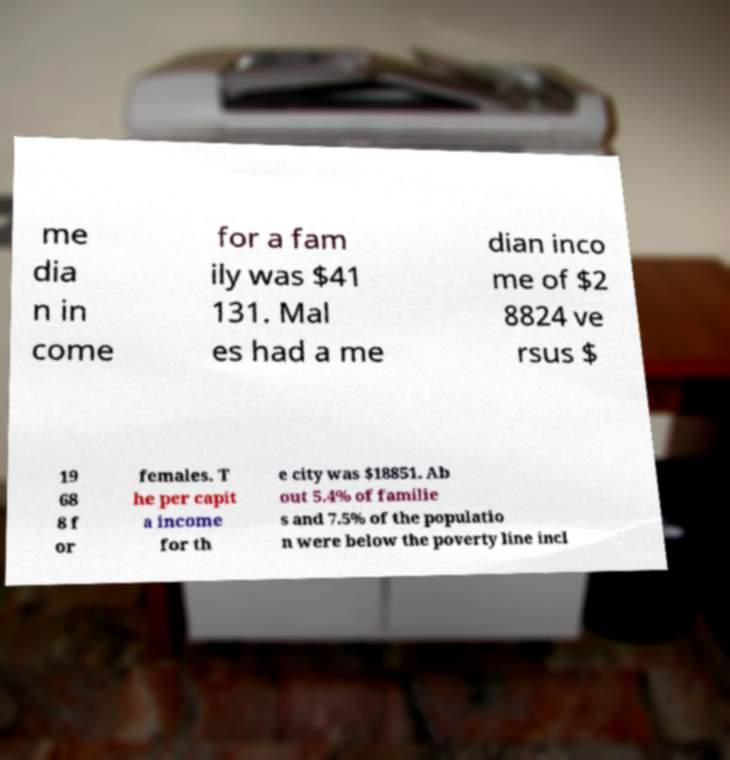Please identify and transcribe the text found in this image. me dia n in come for a fam ily was $41 131. Mal es had a me dian inco me of $2 8824 ve rsus $ 19 68 8 f or females. T he per capit a income for th e city was $18851. Ab out 5.4% of familie s and 7.5% of the populatio n were below the poverty line incl 